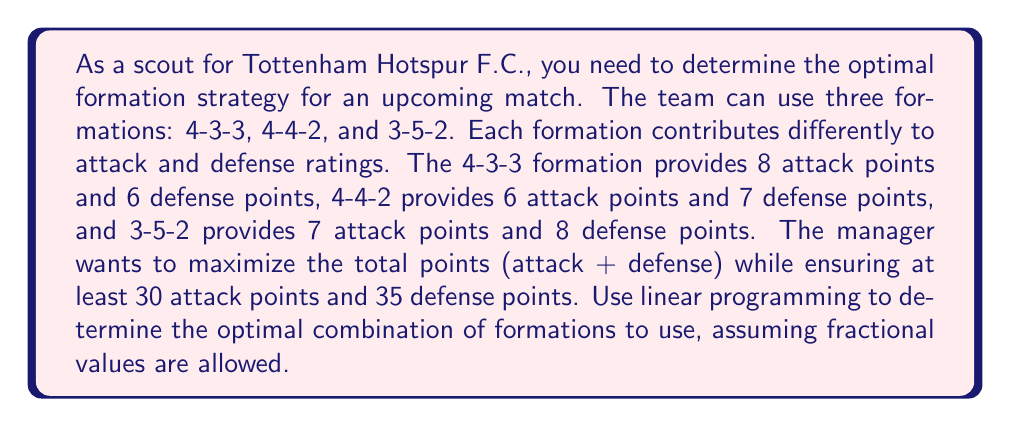Solve this math problem. Let's approach this step-by-step using linear programming:

1) Define variables:
   Let $x_1$ = number of times 4-3-3 is used
   Let $x_2$ = number of times 4-4-2 is used
   Let $x_3$ = number of times 3-5-2 is used

2) Objective function:
   Maximize $Z = (8+6)x_1 + (6+7)x_2 + (7+8)x_3 = 14x_1 + 13x_2 + 15x_3$

3) Constraints:
   Attack: $8x_1 + 6x_2 + 7x_3 \geq 30$
   Defense: $6x_1 + 7x_2 + 8x_3 \geq 35$
   Non-negativity: $x_1, x_2, x_3 \geq 0$

4) Set up the linear programming problem:
   $$\begin{align*}
   \text{Maximize } & Z = 14x_1 + 13x_2 + 15x_3 \\
   \text{Subject to: } & 8x_1 + 6x_2 + 7x_3 \geq 30 \\
   & 6x_1 + 7x_2 + 8x_3 \geq 35 \\
   & x_1, x_2, x_3 \geq 0
   \end{align*}$$

5) Solve using the simplex method or linear programming software:
   The optimal solution is:
   $x_1 = 0, x_2 = 0, x_3 = \frac{35}{8} = 4.375$

6) Interpretation:
   The optimal strategy is to use the 3-5-2 formation 4.375 times (or 87.5% of the time).
   This yields:
   Attack points: $7 * 4.375 = 30.625 \geq 30$
   Defense points: $8 * 4.375 = 35 \geq 35$
   Total points: $15 * 4.375 = 65.625$
Answer: Use 3-5-2 formation 87.5% of the time. 